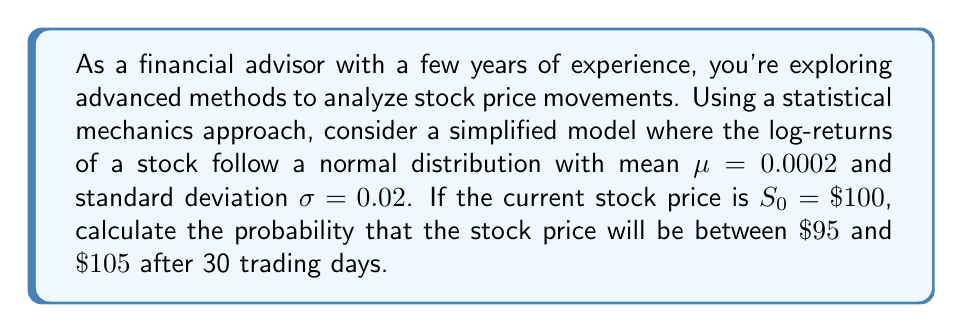Help me with this question. Let's approach this step-by-step using concepts from statistical mechanics:

1) In this model, we assume that the log-returns follow a normal distribution. The price after t days, $S_t$, is related to the initial price $S_0$ by:

   $$S_t = S_0 \exp\left(\left(\mu - \frac{\sigma^2}{2}\right)t + \sigma \sqrt{t} Z\right)$$

   where Z is a standard normal random variable.

2) We need to find $P(95 < S_{30} < 105)$. Let's standardize this:

   $$P\left(\frac{\ln(95/100)}{\sigma\sqrt{30}} < Z < \frac{\ln(105/100)}{\sigma\sqrt{30}}\right)$$

3) Calculate the drift term:
   
   $$\left(\mu - \frac{\sigma^2}{2}\right)t = \left(0.0002 - \frac{0.02^2}{2}\right) \cdot 30 = 0.0054$$

4) Now, let's calculate the lower and upper bounds:

   Lower: $\frac{\ln(95/100) - 0.0054}{0.02\sqrt{30}} = -0.5697$
   
   Upper: $\frac{\ln(105/100) - 0.0054}{0.02\sqrt{30}} = 0.5143$

5) The probability is then:

   $$P(-0.5697 < Z < 0.5143)$$

6) Using the standard normal cumulative distribution function $\Phi$:

   $$\Phi(0.5143) - \Phi(-0.5697)$$

7) Calculating this (you would typically use a calculator or statistical table):

   $$0.6964 - 0.2845 = 0.4119$$
Answer: 0.4119 or 41.19% 